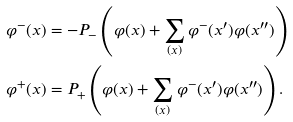<formula> <loc_0><loc_0><loc_500><loc_500>\varphi ^ { - } ( x ) & = - P _ { - } \left ( \varphi ( x ) + \sum _ { ( x ) } \varphi ^ { - } ( x ^ { \prime } ) \varphi ( x ^ { \prime \prime } ) \right ) \\ \varphi ^ { + } ( x ) & = P _ { + } \left ( \varphi ( x ) + \sum _ { ( x ) } \varphi ^ { - } ( x ^ { \prime } ) \varphi ( x ^ { \prime \prime } ) \right ) .</formula> 